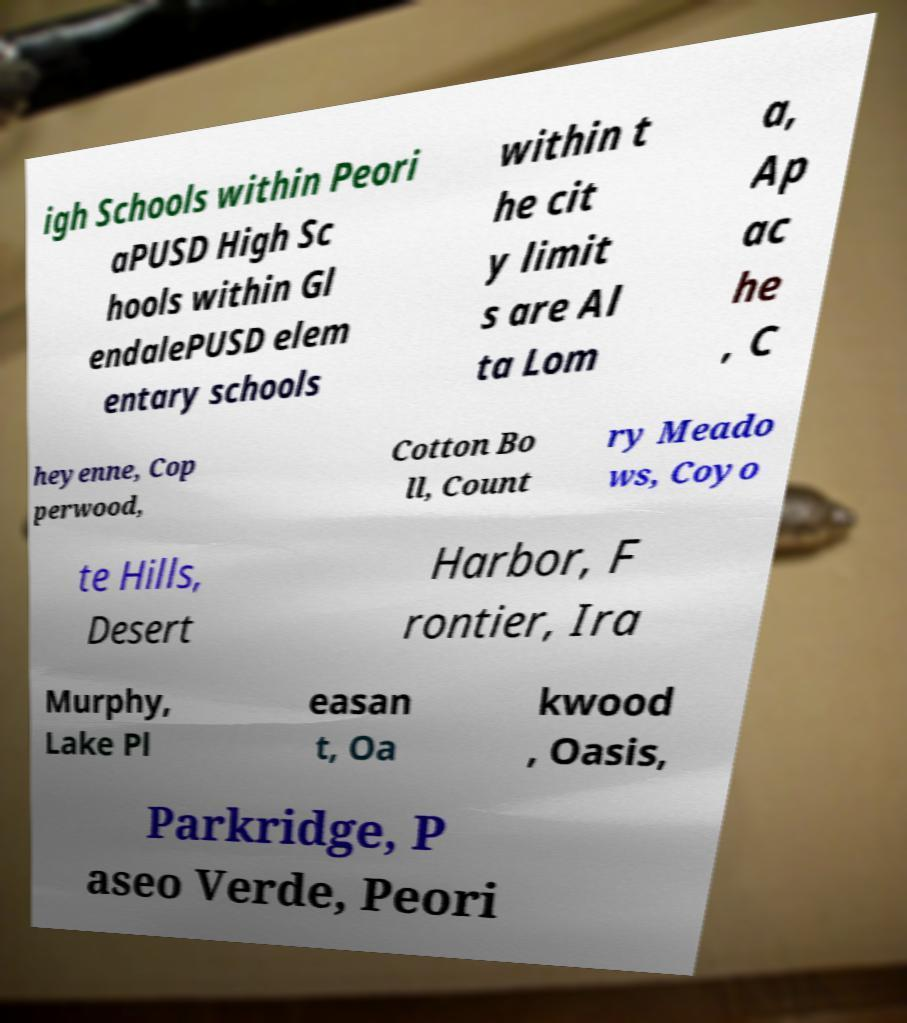For documentation purposes, I need the text within this image transcribed. Could you provide that? igh Schools within Peori aPUSD High Sc hools within Gl endalePUSD elem entary schools within t he cit y limit s are Al ta Lom a, Ap ac he , C heyenne, Cop perwood, Cotton Bo ll, Count ry Meado ws, Coyo te Hills, Desert Harbor, F rontier, Ira Murphy, Lake Pl easan t, Oa kwood , Oasis, Parkridge, P aseo Verde, Peori 